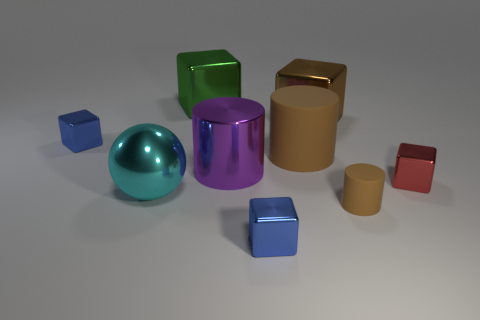Which object seems to reflect light the most, and can you describe its shape? The object reflecting the most light is the spherical one in the center. It has a shiny, turquoise surface that is highly reflective, giving it a bright and glossy appearance. 